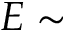Convert formula to latex. <formula><loc_0><loc_0><loc_500><loc_500>E \sim</formula> 